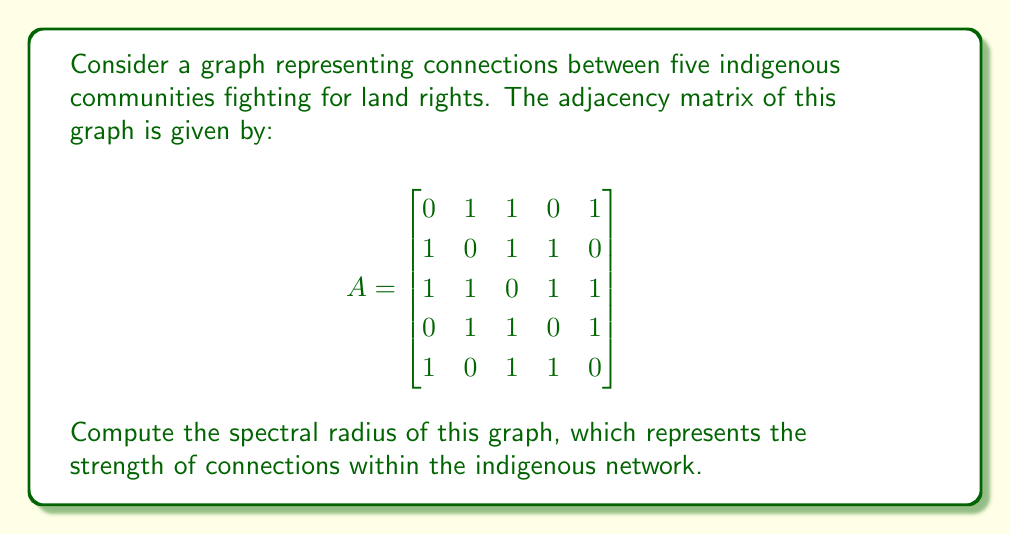Teach me how to tackle this problem. To find the spectral radius of the graph, we need to follow these steps:

1) The spectral radius is the largest absolute eigenvalue of the adjacency matrix.

2) To find the eigenvalues, we need to solve the characteristic equation:
   $\det(A - \lambda I) = 0$

3) Expanding this determinant:
   $$\begin{vmatrix}
   -\lambda & 1 & 1 & 0 & 1 \\
   1 & -\lambda & 1 & 1 & 0 \\
   1 & 1 & -\lambda & 1 & 1 \\
   0 & 1 & 1 & -\lambda & 1 \\
   1 & 0 & 1 & 1 & -\lambda
   \end{vmatrix} = 0$$

4) This expands to the characteristic polynomial:
   $\lambda^5 - 10\lambda^3 - 8\lambda^2 + 5\lambda + 4 = 0$

5) This polynomial is difficult to solve analytically, so we use numerical methods.

6) Using a computer algebra system or numerical method, we find the roots of this polynomial:
   $\lambda_1 \approx 2.6180$
   $\lambda_2 \approx -1.6180$
   $\lambda_3 \approx 1.0000$
   $\lambda_4 \approx -1.0000$
   $\lambda_5 \approx 0.0000$

7) The spectral radius is the largest absolute value among these eigenvalues, which is $\lambda_1 \approx 2.6180$.

8) This value is actually $\frac{1+\sqrt{5}}{2}$, the golden ratio.
Answer: $\frac{1+\sqrt{5}}{2}$ 